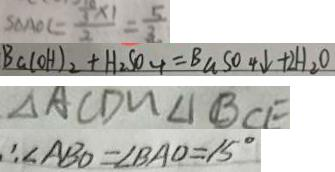<formula> <loc_0><loc_0><loc_500><loc_500>S _ { \Delta A O C } = \frac { \frac { 1 0 } { 3 } \times 1 } { 2 } = \frac { 5 } { 3 } 
 B a ( O H ) _ { 2 } + H _ { 2 } S O _ { 4 } = B a S O 4 \downarrow + 2 H _ { 2 } O 
 \Delta A C D \sim \Delta B C E 
 \therefore \angle A B O = \angle B A O = 1 5 ^ { \circ }</formula> 